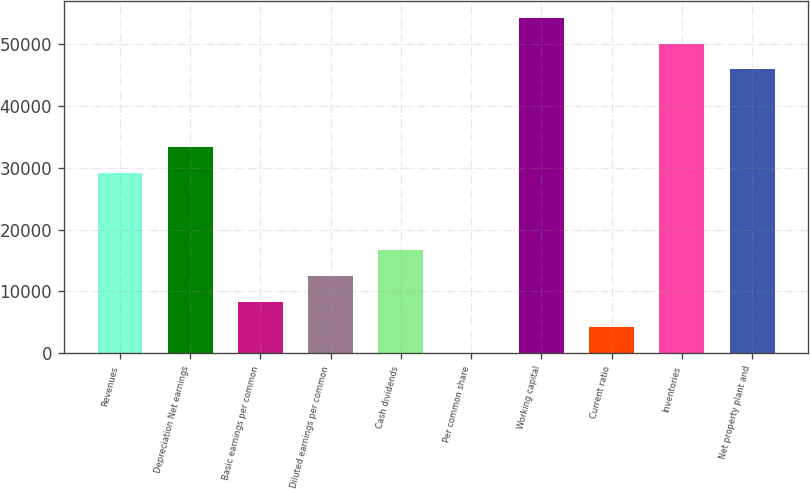<chart> <loc_0><loc_0><loc_500><loc_500><bar_chart><fcel>Revenues<fcel>Depreciation Net earnings<fcel>Basic earnings per common<fcel>Diluted earnings per common<fcel>Cash dividends<fcel>Per common share<fcel>Working capital<fcel>Current ratio<fcel>Inventories<fcel>Net property plant and<nl><fcel>29214<fcel>33387.3<fcel>8347.35<fcel>12520.7<fcel>16694<fcel>0.69<fcel>54254<fcel>4174.02<fcel>50080.7<fcel>45907.3<nl></chart> 